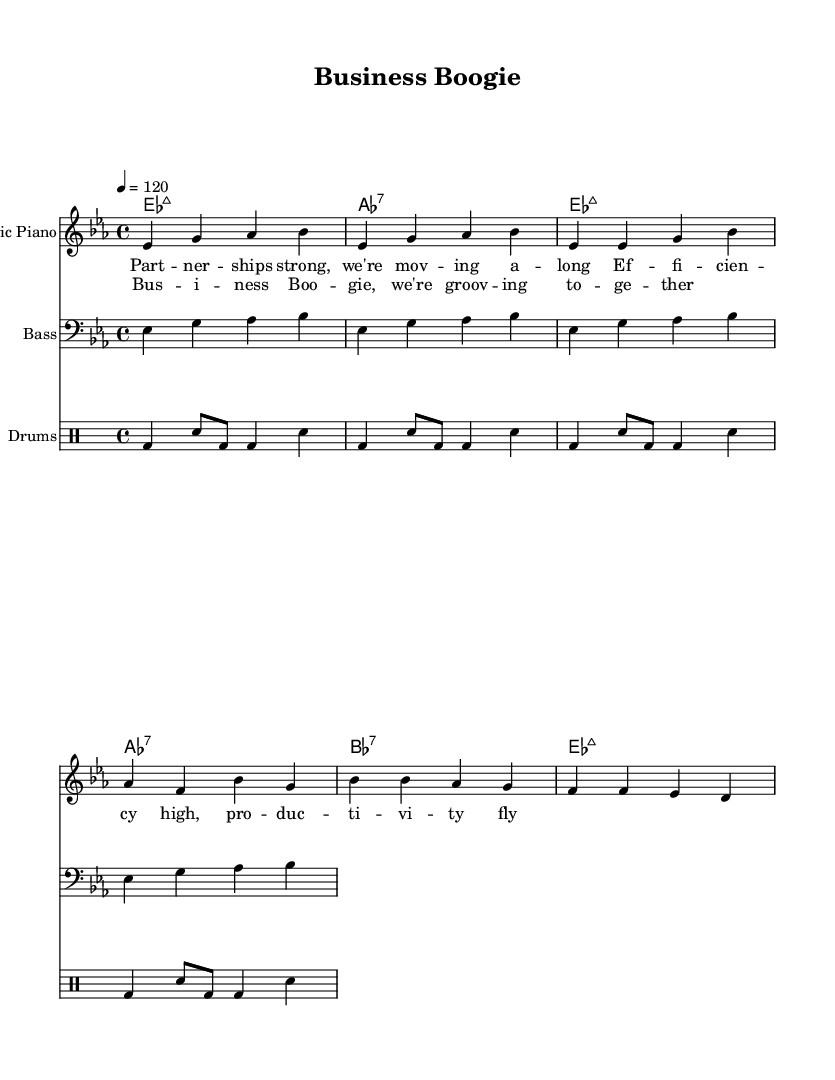What is the key signature of this music? The key signature is E flat major, which has three flat notes: B flat, E flat, and A flat. This can be identified in the sheet music where the flats are indicated at the beginning of the staff.
Answer: E flat major What is the time signature of this piece? The time signature is 4/4, as indicated at the beginning of the sheet music. This means there are four beats in each measure, and the quarter note gets one beat.
Answer: 4/4 What is the tempo marking for this composition? The tempo marking is quarter note equals 120, shown at the beginning of the score. This indicates a moderate disco feel where each quarter note gets 120 beats per minute.
Answer: 120 How many measures are there in the chorus section? There are four measures in the chorus section, as divided in the sheet music and identified by the chord progression and lyrics section corresponding to the chorus.
Answer: 4 What is the main lyrical theme of the verse? The main lyrical theme revolves around strong partnerships and productivity, as specified in the words under the melody in the verse section of the sheet music.
Answer: Partnerships and productivity What type of drum beat is featured in this music? The drum pattern reflects a basic disco beat, characterized by kick drums and snare combinations throughout the sheet music in the drum part section.
Answer: Basic disco beat What is the primary instrument used for the melody? The primary instrument used for the melody is the electric piano, indicated at the beginning of the corresponding staff section in the sheet music.
Answer: Electric piano 